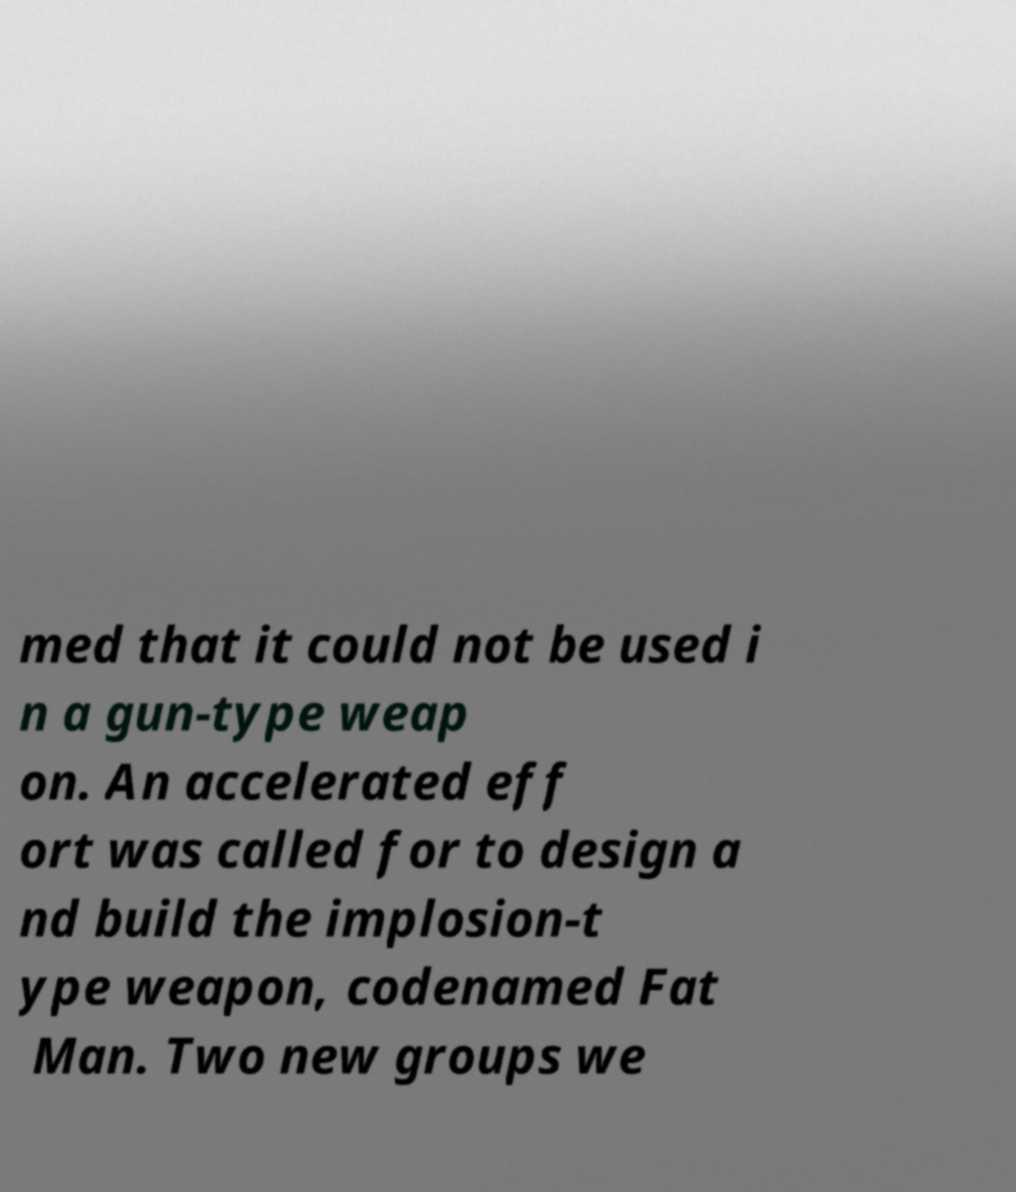What messages or text are displayed in this image? I need them in a readable, typed format. med that it could not be used i n a gun-type weap on. An accelerated eff ort was called for to design a nd build the implosion-t ype weapon, codenamed Fat Man. Two new groups we 